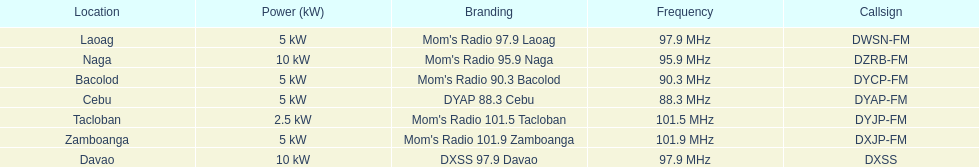How many times is the frequency greater than 95? 5. Can you parse all the data within this table? {'header': ['Location', 'Power (kW)', 'Branding', 'Frequency', 'Callsign'], 'rows': [['Laoag', '5\xa0kW', "Mom's Radio 97.9 Laoag", '97.9\xa0MHz', 'DWSN-FM'], ['Naga', '10\xa0kW', "Mom's Radio 95.9 Naga", '95.9\xa0MHz', 'DZRB-FM'], ['Bacolod', '5\xa0kW', "Mom's Radio 90.3 Bacolod", '90.3\xa0MHz', 'DYCP-FM'], ['Cebu', '5\xa0kW', 'DYAP 88.3 Cebu', '88.3\xa0MHz', 'DYAP-FM'], ['Tacloban', '2.5\xa0kW', "Mom's Radio 101.5 Tacloban", '101.5\xa0MHz', 'DYJP-FM'], ['Zamboanga', '5\xa0kW', "Mom's Radio 101.9 Zamboanga", '101.9\xa0MHz', 'DXJP-FM'], ['Davao', '10\xa0kW', 'DXSS 97.9 Davao', '97.9\xa0MHz', 'DXSS']]} 